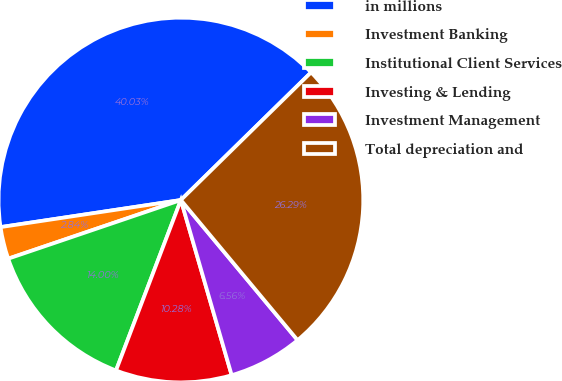Convert chart to OTSL. <chart><loc_0><loc_0><loc_500><loc_500><pie_chart><fcel>in millions<fcel>Investment Banking<fcel>Institutional Client Services<fcel>Investing & Lending<fcel>Investment Management<fcel>Total depreciation and<nl><fcel>40.03%<fcel>2.84%<fcel>14.0%<fcel>10.28%<fcel>6.56%<fcel>26.29%<nl></chart> 